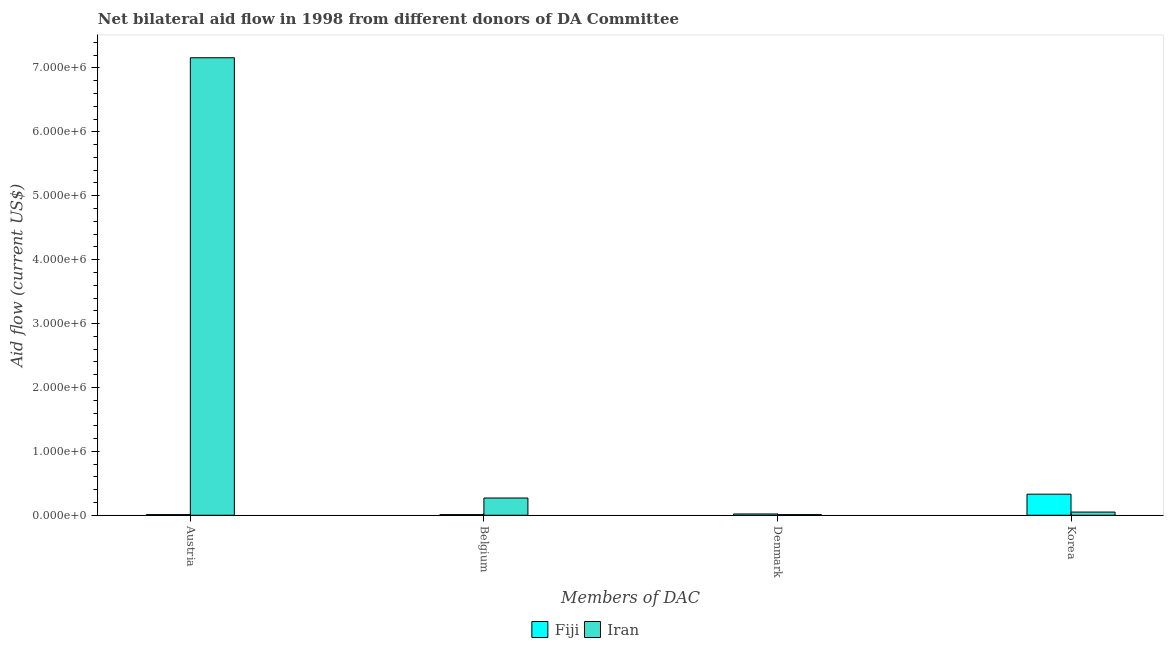How many different coloured bars are there?
Your response must be concise. 2. Are the number of bars on each tick of the X-axis equal?
Your answer should be very brief. Yes. How many bars are there on the 4th tick from the right?
Offer a very short reply. 2. What is the label of the 3rd group of bars from the left?
Ensure brevity in your answer.  Denmark. What is the amount of aid given by austria in Iran?
Keep it short and to the point. 7.16e+06. Across all countries, what is the maximum amount of aid given by korea?
Ensure brevity in your answer.  3.30e+05. Across all countries, what is the minimum amount of aid given by belgium?
Give a very brief answer. 10000. In which country was the amount of aid given by belgium maximum?
Provide a short and direct response. Iran. In which country was the amount of aid given by korea minimum?
Make the answer very short. Iran. What is the total amount of aid given by denmark in the graph?
Offer a terse response. 3.00e+04. What is the difference between the amount of aid given by denmark in Fiji and that in Iran?
Give a very brief answer. 10000. What is the difference between the amount of aid given by korea in Iran and the amount of aid given by belgium in Fiji?
Your answer should be very brief. 4.00e+04. What is the average amount of aid given by denmark per country?
Provide a short and direct response. 1.50e+04. What is the difference between the amount of aid given by belgium and amount of aid given by korea in Fiji?
Ensure brevity in your answer.  -3.20e+05. In how many countries, is the amount of aid given by denmark greater than 3200000 US$?
Your answer should be very brief. 0. Is the amount of aid given by austria in Iran less than that in Fiji?
Offer a terse response. No. Is the difference between the amount of aid given by denmark in Iran and Fiji greater than the difference between the amount of aid given by austria in Iran and Fiji?
Make the answer very short. No. What is the difference between the highest and the second highest amount of aid given by belgium?
Ensure brevity in your answer.  2.60e+05. What is the difference between the highest and the lowest amount of aid given by korea?
Provide a succinct answer. 2.80e+05. In how many countries, is the amount of aid given by austria greater than the average amount of aid given by austria taken over all countries?
Ensure brevity in your answer.  1. Is the sum of the amount of aid given by austria in Iran and Fiji greater than the maximum amount of aid given by denmark across all countries?
Provide a succinct answer. Yes. What does the 2nd bar from the left in Austria represents?
Provide a succinct answer. Iran. What does the 2nd bar from the right in Austria represents?
Your answer should be very brief. Fiji. Are all the bars in the graph horizontal?
Keep it short and to the point. No. How many countries are there in the graph?
Your response must be concise. 2. What is the difference between two consecutive major ticks on the Y-axis?
Make the answer very short. 1.00e+06. Does the graph contain any zero values?
Give a very brief answer. No. Does the graph contain grids?
Your answer should be compact. No. How are the legend labels stacked?
Your response must be concise. Horizontal. What is the title of the graph?
Offer a very short reply. Net bilateral aid flow in 1998 from different donors of DA Committee. Does "Azerbaijan" appear as one of the legend labels in the graph?
Your answer should be very brief. No. What is the label or title of the X-axis?
Keep it short and to the point. Members of DAC. What is the label or title of the Y-axis?
Provide a short and direct response. Aid flow (current US$). What is the Aid flow (current US$) in Iran in Austria?
Provide a short and direct response. 7.16e+06. What is the Aid flow (current US$) in Fiji in Denmark?
Provide a succinct answer. 2.00e+04. What is the Aid flow (current US$) of Iran in Denmark?
Your answer should be compact. 10000. What is the Aid flow (current US$) of Fiji in Korea?
Your answer should be compact. 3.30e+05. Across all Members of DAC, what is the maximum Aid flow (current US$) of Fiji?
Ensure brevity in your answer.  3.30e+05. Across all Members of DAC, what is the maximum Aid flow (current US$) in Iran?
Offer a very short reply. 7.16e+06. What is the total Aid flow (current US$) of Iran in the graph?
Offer a terse response. 7.49e+06. What is the difference between the Aid flow (current US$) in Iran in Austria and that in Belgium?
Provide a succinct answer. 6.89e+06. What is the difference between the Aid flow (current US$) in Fiji in Austria and that in Denmark?
Offer a terse response. -10000. What is the difference between the Aid flow (current US$) in Iran in Austria and that in Denmark?
Offer a terse response. 7.15e+06. What is the difference between the Aid flow (current US$) of Fiji in Austria and that in Korea?
Make the answer very short. -3.20e+05. What is the difference between the Aid flow (current US$) in Iran in Austria and that in Korea?
Ensure brevity in your answer.  7.11e+06. What is the difference between the Aid flow (current US$) of Iran in Belgium and that in Denmark?
Give a very brief answer. 2.60e+05. What is the difference between the Aid flow (current US$) of Fiji in Belgium and that in Korea?
Give a very brief answer. -3.20e+05. What is the difference between the Aid flow (current US$) in Iran in Belgium and that in Korea?
Make the answer very short. 2.20e+05. What is the difference between the Aid flow (current US$) in Fiji in Denmark and that in Korea?
Keep it short and to the point. -3.10e+05. What is the difference between the Aid flow (current US$) of Iran in Denmark and that in Korea?
Offer a terse response. -4.00e+04. What is the difference between the Aid flow (current US$) in Fiji in Austria and the Aid flow (current US$) in Iran in Belgium?
Offer a very short reply. -2.60e+05. What is the difference between the Aid flow (current US$) in Fiji in Austria and the Aid flow (current US$) in Iran in Denmark?
Offer a very short reply. 0. What is the difference between the Aid flow (current US$) in Fiji in Austria and the Aid flow (current US$) in Iran in Korea?
Offer a terse response. -4.00e+04. What is the difference between the Aid flow (current US$) of Fiji in Belgium and the Aid flow (current US$) of Iran in Korea?
Make the answer very short. -4.00e+04. What is the difference between the Aid flow (current US$) of Fiji in Denmark and the Aid flow (current US$) of Iran in Korea?
Offer a terse response. -3.00e+04. What is the average Aid flow (current US$) in Fiji per Members of DAC?
Your answer should be compact. 9.25e+04. What is the average Aid flow (current US$) of Iran per Members of DAC?
Ensure brevity in your answer.  1.87e+06. What is the difference between the Aid flow (current US$) of Fiji and Aid flow (current US$) of Iran in Austria?
Provide a succinct answer. -7.15e+06. What is the difference between the Aid flow (current US$) in Fiji and Aid flow (current US$) in Iran in Belgium?
Your answer should be very brief. -2.60e+05. What is the difference between the Aid flow (current US$) of Fiji and Aid flow (current US$) of Iran in Denmark?
Provide a short and direct response. 10000. What is the difference between the Aid flow (current US$) of Fiji and Aid flow (current US$) of Iran in Korea?
Your answer should be very brief. 2.80e+05. What is the ratio of the Aid flow (current US$) in Iran in Austria to that in Belgium?
Your answer should be compact. 26.52. What is the ratio of the Aid flow (current US$) in Fiji in Austria to that in Denmark?
Provide a short and direct response. 0.5. What is the ratio of the Aid flow (current US$) of Iran in Austria to that in Denmark?
Your answer should be very brief. 716. What is the ratio of the Aid flow (current US$) in Fiji in Austria to that in Korea?
Make the answer very short. 0.03. What is the ratio of the Aid flow (current US$) in Iran in Austria to that in Korea?
Provide a short and direct response. 143.2. What is the ratio of the Aid flow (current US$) of Iran in Belgium to that in Denmark?
Offer a very short reply. 27. What is the ratio of the Aid flow (current US$) in Fiji in Belgium to that in Korea?
Provide a short and direct response. 0.03. What is the ratio of the Aid flow (current US$) in Iran in Belgium to that in Korea?
Your answer should be compact. 5.4. What is the ratio of the Aid flow (current US$) in Fiji in Denmark to that in Korea?
Your answer should be compact. 0.06. What is the ratio of the Aid flow (current US$) of Iran in Denmark to that in Korea?
Offer a very short reply. 0.2. What is the difference between the highest and the second highest Aid flow (current US$) of Fiji?
Offer a terse response. 3.10e+05. What is the difference between the highest and the second highest Aid flow (current US$) in Iran?
Provide a succinct answer. 6.89e+06. What is the difference between the highest and the lowest Aid flow (current US$) in Fiji?
Keep it short and to the point. 3.20e+05. What is the difference between the highest and the lowest Aid flow (current US$) in Iran?
Make the answer very short. 7.15e+06. 